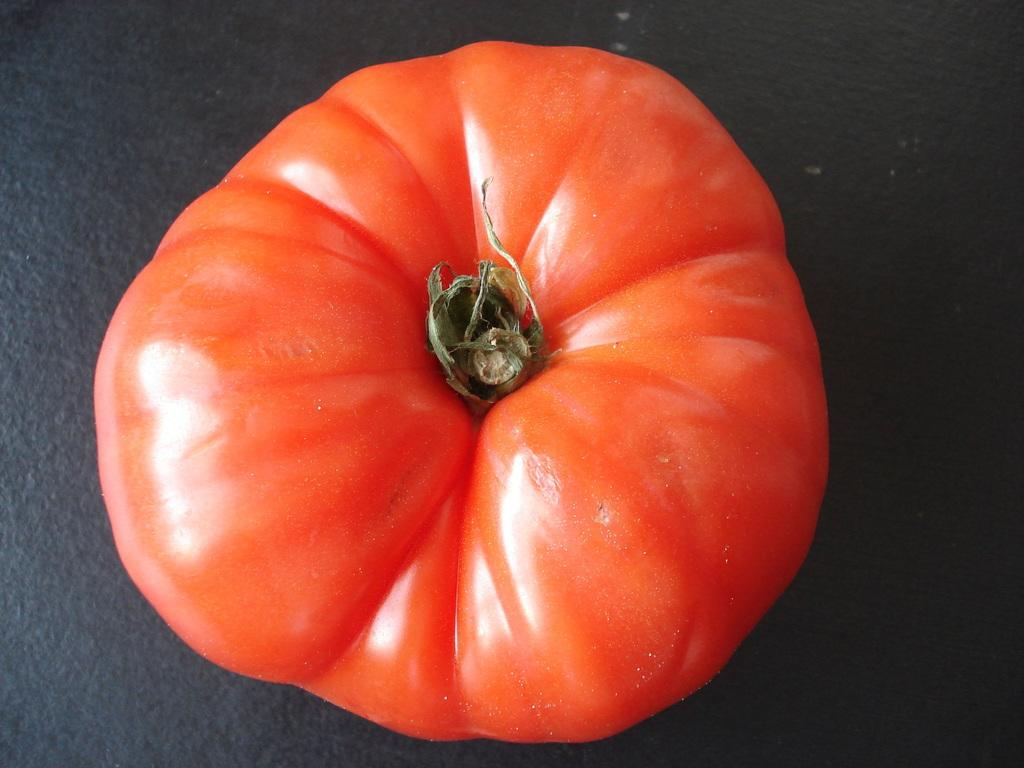What is the main subject of the image? The main subject of the image is a tomato. What is the tomato placed on in the image? The tomato is on a black surface. What type of hair can be seen on the tomato in the image? There is no hair present on the tomato in the image. What type of oatmeal is being served with the tomato in the image? There is no oatmeal present in the image, as it only features a tomato on a black surface. 